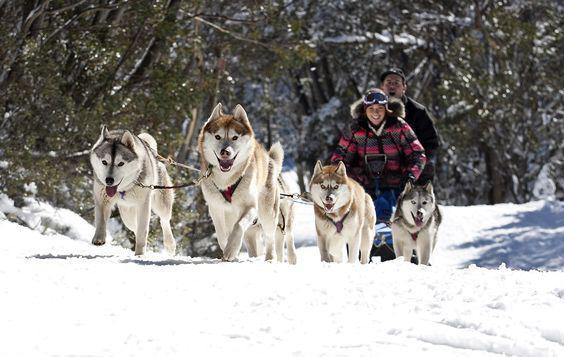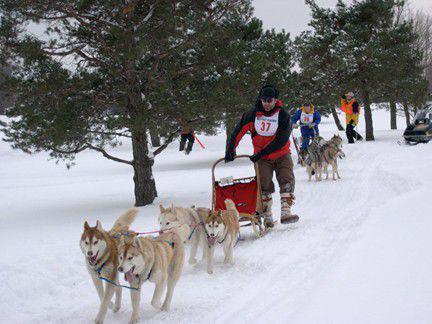The first image is the image on the left, the second image is the image on the right. Evaluate the accuracy of this statement regarding the images: "The dog sled teams in the left and right images appear to be heading toward each other.". Is it true? Answer yes or no. No. The first image is the image on the left, the second image is the image on the right. For the images displayed, is the sentence "One dog is sitting." factually correct? Answer yes or no. No. 